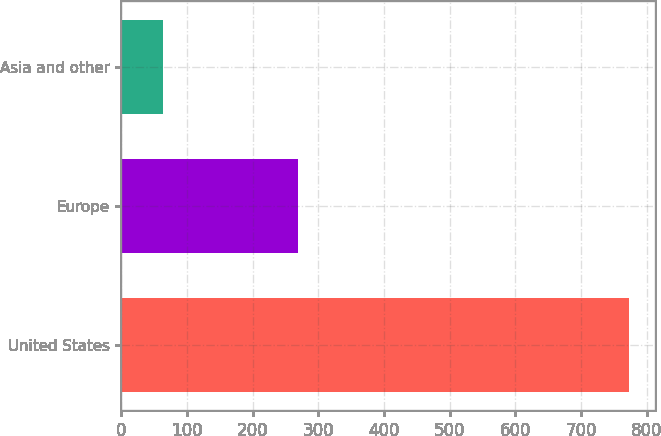<chart> <loc_0><loc_0><loc_500><loc_500><bar_chart><fcel>United States<fcel>Europe<fcel>Asia and other<nl><fcel>774<fcel>269<fcel>64<nl></chart> 